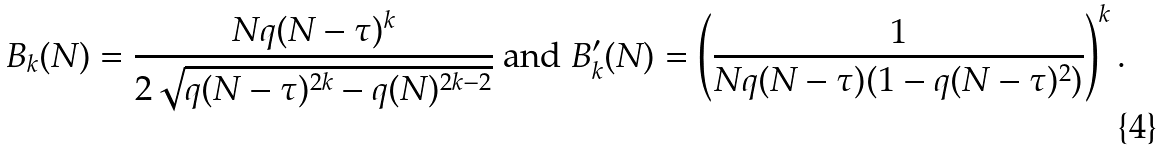<formula> <loc_0><loc_0><loc_500><loc_500>B _ { k } ( N ) = \frac { N q ( N - \tau ) ^ { k } } { 2 \sqrt { q ( N - \tau ) ^ { 2 k } - q ( N ) ^ { 2 k - 2 } } } \text { and } B _ { k } ^ { \prime } ( N ) = \left ( \frac { 1 } { N q ( N - \tau ) ( 1 - q ( N - \tau ) ^ { 2 } ) } \right ) ^ { k } .</formula> 